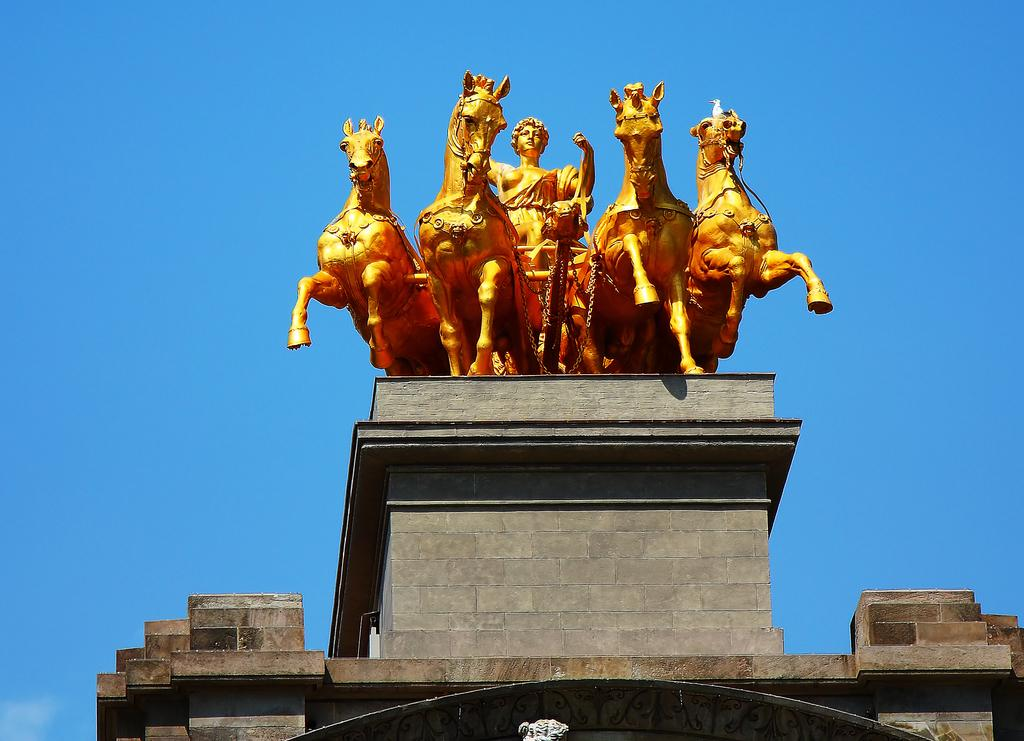What is the main subject of the image? There is a statue in the image. What is depicted on the statue? The statue includes horses. What is located at the bottom of the image? There is a wall at the bottom of the image. What is visible at the top of the image? The sky is visible at the top of the image. What color is the sky in the image? The sky is blue in color. Where is the park located in the image? There is no park present in the image; it features a statue with horses and a wall. Can you tell me how many yards are visible in the image? There is no yard present in the image; it features a statue with horses and a wall. 